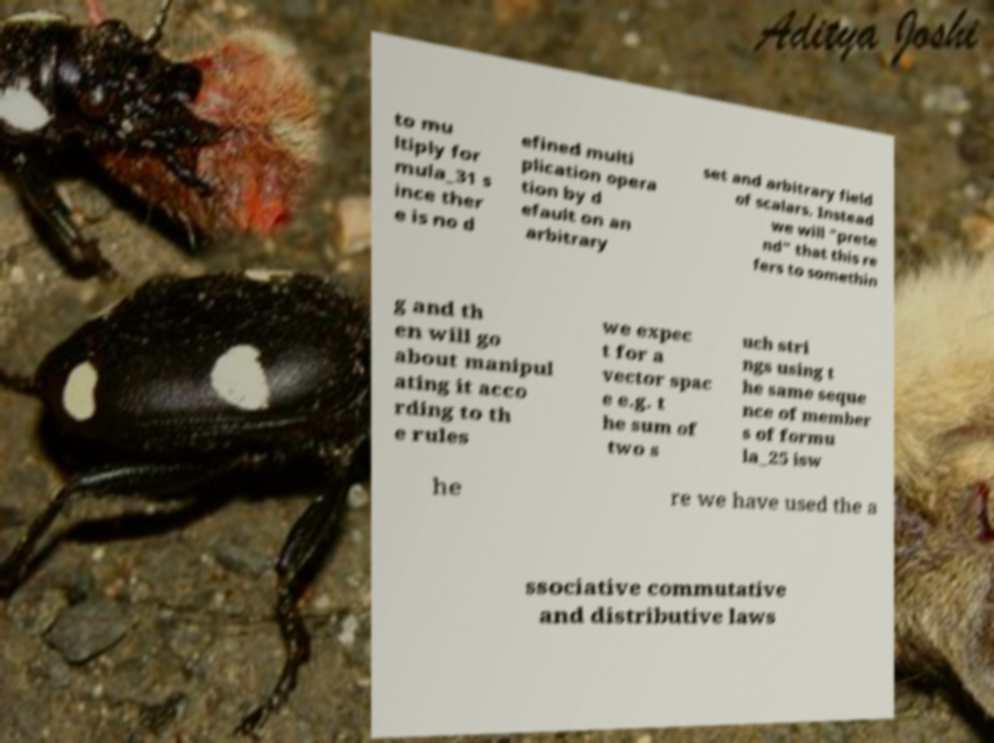Can you read and provide the text displayed in the image?This photo seems to have some interesting text. Can you extract and type it out for me? to mu ltiply for mula_31 s ince ther e is no d efined multi plication opera tion by d efault on an arbitrary set and arbitrary field of scalars. Instead we will "prete nd" that this re fers to somethin g and th en will go about manipul ating it acco rding to th e rules we expec t for a vector spac e e.g. t he sum of two s uch stri ngs using t he same seque nce of member s of formu la_25 isw he re we have used the a ssociative commutative and distributive laws 